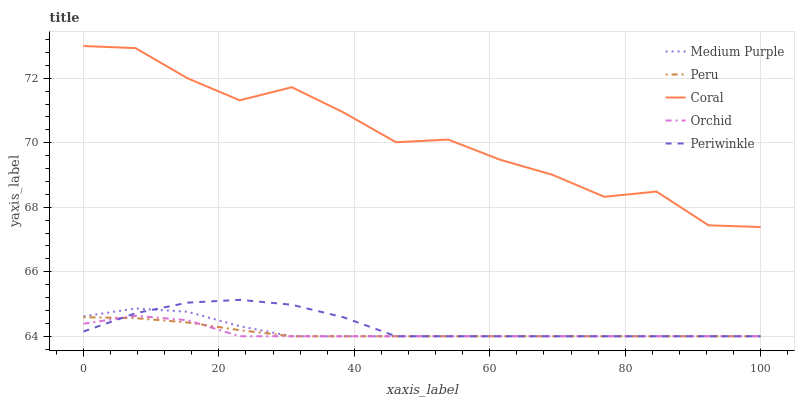Does Orchid have the minimum area under the curve?
Answer yes or no. Yes. Does Coral have the maximum area under the curve?
Answer yes or no. Yes. Does Periwinkle have the minimum area under the curve?
Answer yes or no. No. Does Periwinkle have the maximum area under the curve?
Answer yes or no. No. Is Peru the smoothest?
Answer yes or no. Yes. Is Coral the roughest?
Answer yes or no. Yes. Is Periwinkle the smoothest?
Answer yes or no. No. Is Periwinkle the roughest?
Answer yes or no. No. Does Medium Purple have the lowest value?
Answer yes or no. Yes. Does Coral have the lowest value?
Answer yes or no. No. Does Coral have the highest value?
Answer yes or no. Yes. Does Periwinkle have the highest value?
Answer yes or no. No. Is Orchid less than Coral?
Answer yes or no. Yes. Is Coral greater than Periwinkle?
Answer yes or no. Yes. Does Medium Purple intersect Peru?
Answer yes or no. Yes. Is Medium Purple less than Peru?
Answer yes or no. No. Is Medium Purple greater than Peru?
Answer yes or no. No. Does Orchid intersect Coral?
Answer yes or no. No. 